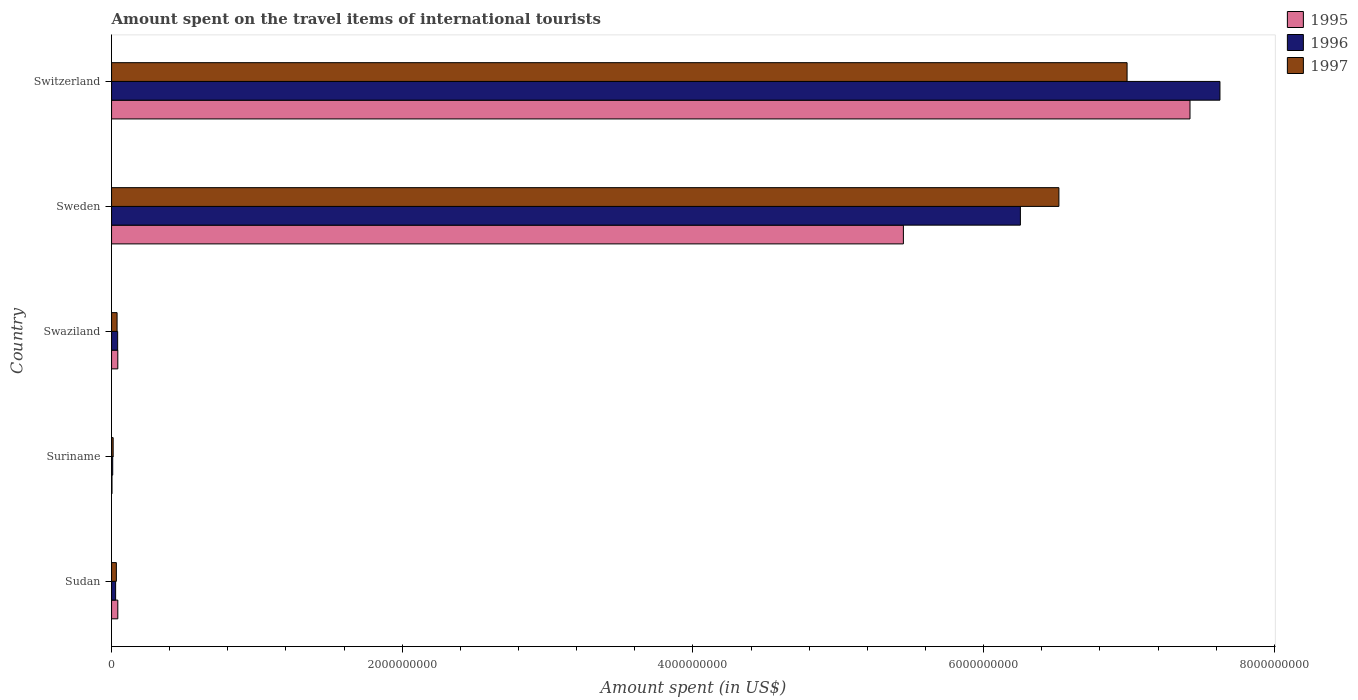How many different coloured bars are there?
Your answer should be very brief. 3. How many groups of bars are there?
Offer a very short reply. 5. Are the number of bars on each tick of the Y-axis equal?
Provide a succinct answer. Yes. What is the label of the 4th group of bars from the top?
Keep it short and to the point. Suriname. In how many cases, is the number of bars for a given country not equal to the number of legend labels?
Keep it short and to the point. 0. What is the amount spent on the travel items of international tourists in 1995 in Swaziland?
Your answer should be very brief. 4.30e+07. Across all countries, what is the maximum amount spent on the travel items of international tourists in 1997?
Your response must be concise. 6.99e+09. In which country was the amount spent on the travel items of international tourists in 1997 maximum?
Keep it short and to the point. Switzerland. In which country was the amount spent on the travel items of international tourists in 1996 minimum?
Provide a succinct answer. Suriname. What is the total amount spent on the travel items of international tourists in 1997 in the graph?
Your answer should be very brief. 1.36e+1. What is the difference between the amount spent on the travel items of international tourists in 1996 in Suriname and that in Sweden?
Your response must be concise. -6.24e+09. What is the difference between the amount spent on the travel items of international tourists in 1997 in Sudan and the amount spent on the travel items of international tourists in 1996 in Suriname?
Offer a very short reply. 2.50e+07. What is the average amount spent on the travel items of international tourists in 1995 per country?
Provide a short and direct response. 2.59e+09. What is the difference between the amount spent on the travel items of international tourists in 1995 and amount spent on the travel items of international tourists in 1997 in Suriname?
Your answer should be compact. -8.00e+06. In how many countries, is the amount spent on the travel items of international tourists in 1995 greater than 400000000 US$?
Offer a very short reply. 2. What is the ratio of the amount spent on the travel items of international tourists in 1995 in Sudan to that in Switzerland?
Provide a short and direct response. 0.01. Is the amount spent on the travel items of international tourists in 1995 in Sudan less than that in Suriname?
Give a very brief answer. No. What is the difference between the highest and the second highest amount spent on the travel items of international tourists in 1996?
Offer a terse response. 1.37e+09. What is the difference between the highest and the lowest amount spent on the travel items of international tourists in 1996?
Offer a terse response. 7.62e+09. What does the 1st bar from the top in Suriname represents?
Make the answer very short. 1997. What does the 1st bar from the bottom in Sudan represents?
Keep it short and to the point. 1995. Is it the case that in every country, the sum of the amount spent on the travel items of international tourists in 1997 and amount spent on the travel items of international tourists in 1995 is greater than the amount spent on the travel items of international tourists in 1996?
Your answer should be compact. Yes. Are all the bars in the graph horizontal?
Offer a terse response. Yes. What is the difference between two consecutive major ticks on the X-axis?
Ensure brevity in your answer.  2.00e+09. Are the values on the major ticks of X-axis written in scientific E-notation?
Your answer should be very brief. No. Does the graph contain any zero values?
Offer a very short reply. No. Does the graph contain grids?
Keep it short and to the point. No. What is the title of the graph?
Offer a very short reply. Amount spent on the travel items of international tourists. Does "1977" appear as one of the legend labels in the graph?
Ensure brevity in your answer.  No. What is the label or title of the X-axis?
Offer a terse response. Amount spent (in US$). What is the label or title of the Y-axis?
Your answer should be very brief. Country. What is the Amount spent (in US$) in 1995 in Sudan?
Make the answer very short. 4.30e+07. What is the Amount spent (in US$) in 1996 in Sudan?
Your answer should be very brief. 2.80e+07. What is the Amount spent (in US$) of 1997 in Sudan?
Your response must be concise. 3.30e+07. What is the Amount spent (in US$) in 1996 in Suriname?
Your answer should be compact. 8.00e+06. What is the Amount spent (in US$) of 1997 in Suriname?
Offer a very short reply. 1.10e+07. What is the Amount spent (in US$) of 1995 in Swaziland?
Your answer should be compact. 4.30e+07. What is the Amount spent (in US$) in 1996 in Swaziland?
Provide a short and direct response. 4.20e+07. What is the Amount spent (in US$) in 1997 in Swaziland?
Your response must be concise. 3.80e+07. What is the Amount spent (in US$) of 1995 in Sweden?
Your response must be concise. 5.45e+09. What is the Amount spent (in US$) in 1996 in Sweden?
Offer a terse response. 6.25e+09. What is the Amount spent (in US$) of 1997 in Sweden?
Your response must be concise. 6.52e+09. What is the Amount spent (in US$) of 1995 in Switzerland?
Offer a very short reply. 7.42e+09. What is the Amount spent (in US$) in 1996 in Switzerland?
Offer a very short reply. 7.63e+09. What is the Amount spent (in US$) in 1997 in Switzerland?
Ensure brevity in your answer.  6.99e+09. Across all countries, what is the maximum Amount spent (in US$) in 1995?
Provide a short and direct response. 7.42e+09. Across all countries, what is the maximum Amount spent (in US$) of 1996?
Your answer should be very brief. 7.63e+09. Across all countries, what is the maximum Amount spent (in US$) in 1997?
Offer a very short reply. 6.99e+09. Across all countries, what is the minimum Amount spent (in US$) of 1995?
Keep it short and to the point. 3.00e+06. Across all countries, what is the minimum Amount spent (in US$) of 1997?
Offer a very short reply. 1.10e+07. What is the total Amount spent (in US$) in 1995 in the graph?
Ensure brevity in your answer.  1.30e+1. What is the total Amount spent (in US$) of 1996 in the graph?
Your response must be concise. 1.40e+1. What is the total Amount spent (in US$) in 1997 in the graph?
Make the answer very short. 1.36e+1. What is the difference between the Amount spent (in US$) of 1995 in Sudan and that in Suriname?
Your answer should be compact. 4.00e+07. What is the difference between the Amount spent (in US$) of 1996 in Sudan and that in Suriname?
Offer a terse response. 2.00e+07. What is the difference between the Amount spent (in US$) in 1997 in Sudan and that in Suriname?
Your response must be concise. 2.20e+07. What is the difference between the Amount spent (in US$) of 1996 in Sudan and that in Swaziland?
Provide a short and direct response. -1.40e+07. What is the difference between the Amount spent (in US$) of 1997 in Sudan and that in Swaziland?
Ensure brevity in your answer.  -5.00e+06. What is the difference between the Amount spent (in US$) in 1995 in Sudan and that in Sweden?
Offer a very short reply. -5.40e+09. What is the difference between the Amount spent (in US$) in 1996 in Sudan and that in Sweden?
Your answer should be compact. -6.22e+09. What is the difference between the Amount spent (in US$) of 1997 in Sudan and that in Sweden?
Make the answer very short. -6.48e+09. What is the difference between the Amount spent (in US$) in 1995 in Sudan and that in Switzerland?
Your answer should be very brief. -7.38e+09. What is the difference between the Amount spent (in US$) of 1996 in Sudan and that in Switzerland?
Offer a very short reply. -7.60e+09. What is the difference between the Amount spent (in US$) of 1997 in Sudan and that in Switzerland?
Make the answer very short. -6.95e+09. What is the difference between the Amount spent (in US$) in 1995 in Suriname and that in Swaziland?
Ensure brevity in your answer.  -4.00e+07. What is the difference between the Amount spent (in US$) of 1996 in Suriname and that in Swaziland?
Make the answer very short. -3.40e+07. What is the difference between the Amount spent (in US$) of 1997 in Suriname and that in Swaziland?
Provide a short and direct response. -2.70e+07. What is the difference between the Amount spent (in US$) in 1995 in Suriname and that in Sweden?
Provide a succinct answer. -5.44e+09. What is the difference between the Amount spent (in US$) of 1996 in Suriname and that in Sweden?
Offer a terse response. -6.24e+09. What is the difference between the Amount spent (in US$) of 1997 in Suriname and that in Sweden?
Offer a terse response. -6.51e+09. What is the difference between the Amount spent (in US$) of 1995 in Suriname and that in Switzerland?
Offer a terse response. -7.42e+09. What is the difference between the Amount spent (in US$) of 1996 in Suriname and that in Switzerland?
Provide a short and direct response. -7.62e+09. What is the difference between the Amount spent (in US$) of 1997 in Suriname and that in Switzerland?
Provide a short and direct response. -6.98e+09. What is the difference between the Amount spent (in US$) of 1995 in Swaziland and that in Sweden?
Give a very brief answer. -5.40e+09. What is the difference between the Amount spent (in US$) of 1996 in Swaziland and that in Sweden?
Keep it short and to the point. -6.21e+09. What is the difference between the Amount spent (in US$) in 1997 in Swaziland and that in Sweden?
Keep it short and to the point. -6.48e+09. What is the difference between the Amount spent (in US$) of 1995 in Swaziland and that in Switzerland?
Give a very brief answer. -7.38e+09. What is the difference between the Amount spent (in US$) in 1996 in Swaziland and that in Switzerland?
Ensure brevity in your answer.  -7.58e+09. What is the difference between the Amount spent (in US$) in 1997 in Swaziland and that in Switzerland?
Provide a succinct answer. -6.95e+09. What is the difference between the Amount spent (in US$) of 1995 in Sweden and that in Switzerland?
Provide a short and direct response. -1.97e+09. What is the difference between the Amount spent (in US$) in 1996 in Sweden and that in Switzerland?
Make the answer very short. -1.37e+09. What is the difference between the Amount spent (in US$) of 1997 in Sweden and that in Switzerland?
Provide a succinct answer. -4.69e+08. What is the difference between the Amount spent (in US$) in 1995 in Sudan and the Amount spent (in US$) in 1996 in Suriname?
Ensure brevity in your answer.  3.50e+07. What is the difference between the Amount spent (in US$) of 1995 in Sudan and the Amount spent (in US$) of 1997 in Suriname?
Your response must be concise. 3.20e+07. What is the difference between the Amount spent (in US$) of 1996 in Sudan and the Amount spent (in US$) of 1997 in Suriname?
Keep it short and to the point. 1.70e+07. What is the difference between the Amount spent (in US$) of 1995 in Sudan and the Amount spent (in US$) of 1996 in Swaziland?
Ensure brevity in your answer.  1.00e+06. What is the difference between the Amount spent (in US$) in 1995 in Sudan and the Amount spent (in US$) in 1997 in Swaziland?
Provide a succinct answer. 5.00e+06. What is the difference between the Amount spent (in US$) of 1996 in Sudan and the Amount spent (in US$) of 1997 in Swaziland?
Your answer should be compact. -1.00e+07. What is the difference between the Amount spent (in US$) in 1995 in Sudan and the Amount spent (in US$) in 1996 in Sweden?
Make the answer very short. -6.21e+09. What is the difference between the Amount spent (in US$) of 1995 in Sudan and the Amount spent (in US$) of 1997 in Sweden?
Your answer should be compact. -6.48e+09. What is the difference between the Amount spent (in US$) of 1996 in Sudan and the Amount spent (in US$) of 1997 in Sweden?
Provide a short and direct response. -6.49e+09. What is the difference between the Amount spent (in US$) of 1995 in Sudan and the Amount spent (in US$) of 1996 in Switzerland?
Your answer should be compact. -7.58e+09. What is the difference between the Amount spent (in US$) of 1995 in Sudan and the Amount spent (in US$) of 1997 in Switzerland?
Give a very brief answer. -6.94e+09. What is the difference between the Amount spent (in US$) of 1996 in Sudan and the Amount spent (in US$) of 1997 in Switzerland?
Keep it short and to the point. -6.96e+09. What is the difference between the Amount spent (in US$) in 1995 in Suriname and the Amount spent (in US$) in 1996 in Swaziland?
Provide a short and direct response. -3.90e+07. What is the difference between the Amount spent (in US$) of 1995 in Suriname and the Amount spent (in US$) of 1997 in Swaziland?
Offer a very short reply. -3.50e+07. What is the difference between the Amount spent (in US$) in 1996 in Suriname and the Amount spent (in US$) in 1997 in Swaziland?
Your response must be concise. -3.00e+07. What is the difference between the Amount spent (in US$) of 1995 in Suriname and the Amount spent (in US$) of 1996 in Sweden?
Provide a succinct answer. -6.25e+09. What is the difference between the Amount spent (in US$) in 1995 in Suriname and the Amount spent (in US$) in 1997 in Sweden?
Give a very brief answer. -6.52e+09. What is the difference between the Amount spent (in US$) in 1996 in Suriname and the Amount spent (in US$) in 1997 in Sweden?
Make the answer very short. -6.51e+09. What is the difference between the Amount spent (in US$) in 1995 in Suriname and the Amount spent (in US$) in 1996 in Switzerland?
Provide a short and direct response. -7.62e+09. What is the difference between the Amount spent (in US$) in 1995 in Suriname and the Amount spent (in US$) in 1997 in Switzerland?
Offer a very short reply. -6.98e+09. What is the difference between the Amount spent (in US$) of 1996 in Suriname and the Amount spent (in US$) of 1997 in Switzerland?
Offer a very short reply. -6.98e+09. What is the difference between the Amount spent (in US$) in 1995 in Swaziland and the Amount spent (in US$) in 1996 in Sweden?
Your answer should be compact. -6.21e+09. What is the difference between the Amount spent (in US$) in 1995 in Swaziland and the Amount spent (in US$) in 1997 in Sweden?
Provide a succinct answer. -6.48e+09. What is the difference between the Amount spent (in US$) of 1996 in Swaziland and the Amount spent (in US$) of 1997 in Sweden?
Your answer should be compact. -6.48e+09. What is the difference between the Amount spent (in US$) in 1995 in Swaziland and the Amount spent (in US$) in 1996 in Switzerland?
Give a very brief answer. -7.58e+09. What is the difference between the Amount spent (in US$) of 1995 in Swaziland and the Amount spent (in US$) of 1997 in Switzerland?
Ensure brevity in your answer.  -6.94e+09. What is the difference between the Amount spent (in US$) in 1996 in Swaziland and the Amount spent (in US$) in 1997 in Switzerland?
Keep it short and to the point. -6.94e+09. What is the difference between the Amount spent (in US$) of 1995 in Sweden and the Amount spent (in US$) of 1996 in Switzerland?
Your answer should be compact. -2.18e+09. What is the difference between the Amount spent (in US$) of 1995 in Sweden and the Amount spent (in US$) of 1997 in Switzerland?
Give a very brief answer. -1.54e+09. What is the difference between the Amount spent (in US$) in 1996 in Sweden and the Amount spent (in US$) in 1997 in Switzerland?
Make the answer very short. -7.34e+08. What is the average Amount spent (in US$) of 1995 per country?
Your response must be concise. 2.59e+09. What is the average Amount spent (in US$) in 1996 per country?
Provide a short and direct response. 2.79e+09. What is the average Amount spent (in US$) in 1997 per country?
Keep it short and to the point. 2.72e+09. What is the difference between the Amount spent (in US$) in 1995 and Amount spent (in US$) in 1996 in Sudan?
Keep it short and to the point. 1.50e+07. What is the difference between the Amount spent (in US$) of 1995 and Amount spent (in US$) of 1997 in Sudan?
Provide a short and direct response. 1.00e+07. What is the difference between the Amount spent (in US$) of 1996 and Amount spent (in US$) of 1997 in Sudan?
Your response must be concise. -5.00e+06. What is the difference between the Amount spent (in US$) of 1995 and Amount spent (in US$) of 1996 in Suriname?
Make the answer very short. -5.00e+06. What is the difference between the Amount spent (in US$) in 1995 and Amount spent (in US$) in 1997 in Suriname?
Ensure brevity in your answer.  -8.00e+06. What is the difference between the Amount spent (in US$) of 1995 and Amount spent (in US$) of 1996 in Swaziland?
Keep it short and to the point. 1.00e+06. What is the difference between the Amount spent (in US$) in 1995 and Amount spent (in US$) in 1997 in Swaziland?
Your answer should be compact. 5.00e+06. What is the difference between the Amount spent (in US$) in 1995 and Amount spent (in US$) in 1996 in Sweden?
Provide a succinct answer. -8.05e+08. What is the difference between the Amount spent (in US$) of 1995 and Amount spent (in US$) of 1997 in Sweden?
Offer a terse response. -1.07e+09. What is the difference between the Amount spent (in US$) of 1996 and Amount spent (in US$) of 1997 in Sweden?
Offer a terse response. -2.65e+08. What is the difference between the Amount spent (in US$) in 1995 and Amount spent (in US$) in 1996 in Switzerland?
Offer a terse response. -2.06e+08. What is the difference between the Amount spent (in US$) of 1995 and Amount spent (in US$) of 1997 in Switzerland?
Your response must be concise. 4.33e+08. What is the difference between the Amount spent (in US$) in 1996 and Amount spent (in US$) in 1997 in Switzerland?
Keep it short and to the point. 6.39e+08. What is the ratio of the Amount spent (in US$) in 1995 in Sudan to that in Suriname?
Provide a short and direct response. 14.33. What is the ratio of the Amount spent (in US$) of 1995 in Sudan to that in Swaziland?
Provide a short and direct response. 1. What is the ratio of the Amount spent (in US$) in 1996 in Sudan to that in Swaziland?
Provide a short and direct response. 0.67. What is the ratio of the Amount spent (in US$) in 1997 in Sudan to that in Swaziland?
Offer a very short reply. 0.87. What is the ratio of the Amount spent (in US$) of 1995 in Sudan to that in Sweden?
Keep it short and to the point. 0.01. What is the ratio of the Amount spent (in US$) of 1996 in Sudan to that in Sweden?
Your response must be concise. 0. What is the ratio of the Amount spent (in US$) in 1997 in Sudan to that in Sweden?
Give a very brief answer. 0.01. What is the ratio of the Amount spent (in US$) of 1995 in Sudan to that in Switzerland?
Provide a succinct answer. 0.01. What is the ratio of the Amount spent (in US$) in 1996 in Sudan to that in Switzerland?
Your response must be concise. 0. What is the ratio of the Amount spent (in US$) in 1997 in Sudan to that in Switzerland?
Offer a very short reply. 0. What is the ratio of the Amount spent (in US$) of 1995 in Suriname to that in Swaziland?
Offer a terse response. 0.07. What is the ratio of the Amount spent (in US$) of 1996 in Suriname to that in Swaziland?
Ensure brevity in your answer.  0.19. What is the ratio of the Amount spent (in US$) in 1997 in Suriname to that in Swaziland?
Make the answer very short. 0.29. What is the ratio of the Amount spent (in US$) of 1995 in Suriname to that in Sweden?
Your answer should be very brief. 0. What is the ratio of the Amount spent (in US$) of 1996 in Suriname to that in Sweden?
Make the answer very short. 0. What is the ratio of the Amount spent (in US$) of 1997 in Suriname to that in Sweden?
Your answer should be compact. 0. What is the ratio of the Amount spent (in US$) in 1995 in Suriname to that in Switzerland?
Offer a very short reply. 0. What is the ratio of the Amount spent (in US$) in 1996 in Suriname to that in Switzerland?
Make the answer very short. 0. What is the ratio of the Amount spent (in US$) of 1997 in Suriname to that in Switzerland?
Provide a short and direct response. 0. What is the ratio of the Amount spent (in US$) in 1995 in Swaziland to that in Sweden?
Your response must be concise. 0.01. What is the ratio of the Amount spent (in US$) in 1996 in Swaziland to that in Sweden?
Give a very brief answer. 0.01. What is the ratio of the Amount spent (in US$) of 1997 in Swaziland to that in Sweden?
Make the answer very short. 0.01. What is the ratio of the Amount spent (in US$) in 1995 in Swaziland to that in Switzerland?
Offer a very short reply. 0.01. What is the ratio of the Amount spent (in US$) of 1996 in Swaziland to that in Switzerland?
Provide a short and direct response. 0.01. What is the ratio of the Amount spent (in US$) in 1997 in Swaziland to that in Switzerland?
Make the answer very short. 0.01. What is the ratio of the Amount spent (in US$) of 1995 in Sweden to that in Switzerland?
Provide a short and direct response. 0.73. What is the ratio of the Amount spent (in US$) of 1996 in Sweden to that in Switzerland?
Offer a terse response. 0.82. What is the ratio of the Amount spent (in US$) of 1997 in Sweden to that in Switzerland?
Keep it short and to the point. 0.93. What is the difference between the highest and the second highest Amount spent (in US$) of 1995?
Your answer should be compact. 1.97e+09. What is the difference between the highest and the second highest Amount spent (in US$) in 1996?
Give a very brief answer. 1.37e+09. What is the difference between the highest and the second highest Amount spent (in US$) of 1997?
Your answer should be compact. 4.69e+08. What is the difference between the highest and the lowest Amount spent (in US$) of 1995?
Your answer should be compact. 7.42e+09. What is the difference between the highest and the lowest Amount spent (in US$) of 1996?
Your answer should be compact. 7.62e+09. What is the difference between the highest and the lowest Amount spent (in US$) in 1997?
Your response must be concise. 6.98e+09. 